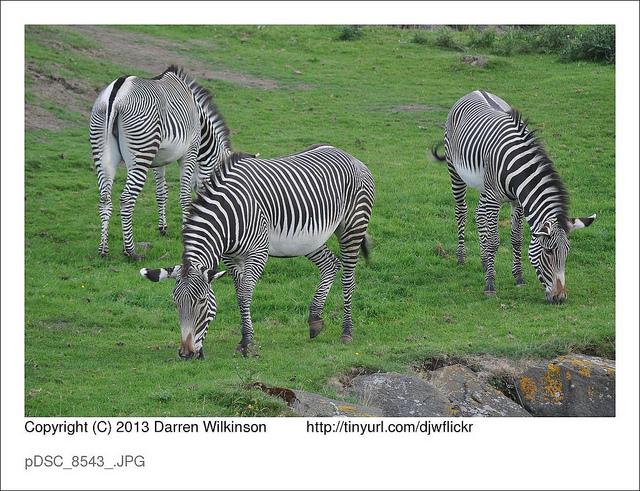Where is the picture taken?
Give a very brief answer. Zoo. How many alligators?
Short answer required. 0. What are the zebras eating?
Short answer required. Grass. 